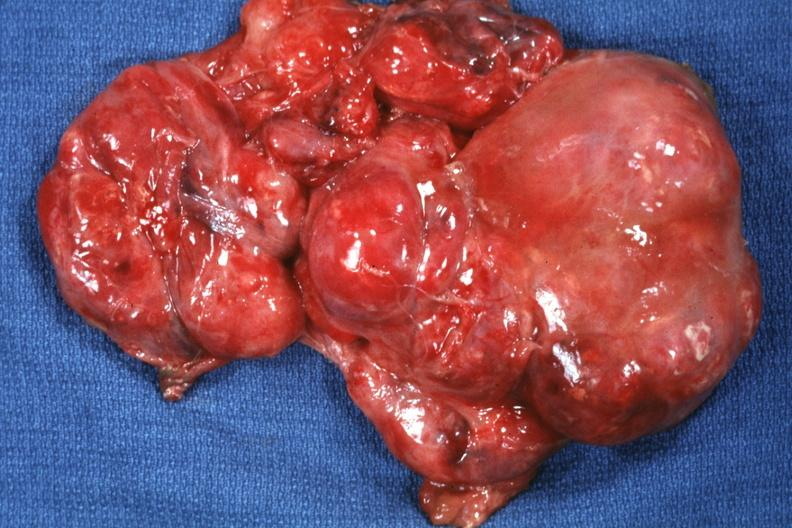what is present?
Answer the question using a single word or phrase. Sacrococcygeal teratoma 